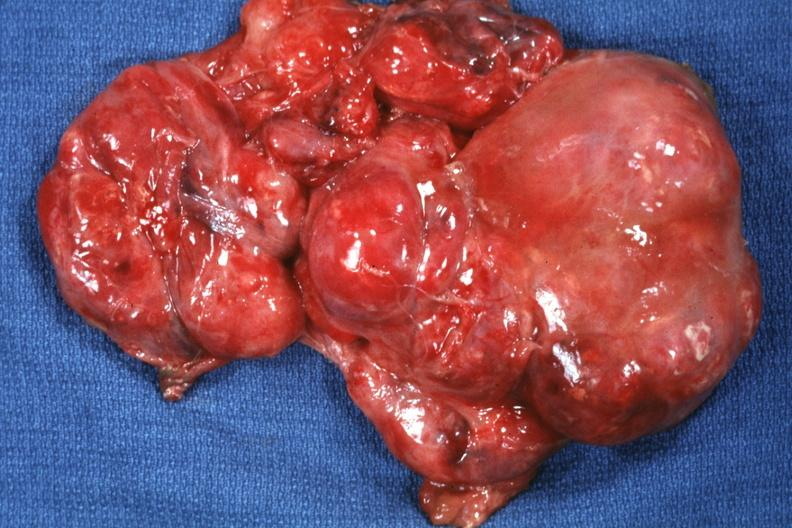what is present?
Answer the question using a single word or phrase. Sacrococcygeal teratoma 